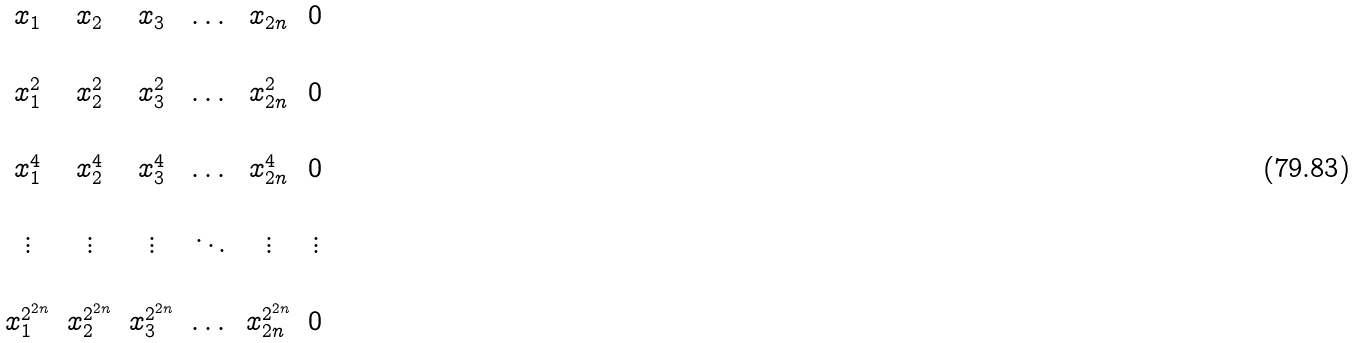<formula> <loc_0><loc_0><loc_500><loc_500>\begin{matrix} x _ { 1 } & x _ { 2 } & x _ { 3 } & \dots & x _ { 2 n } & 0 \\ \\ x _ { 1 } ^ { 2 } & x _ { 2 } ^ { 2 } & x _ { 3 } ^ { 2 } & \dots & x _ { 2 n } ^ { 2 } & 0 \\ \\ x _ { 1 } ^ { 4 } & x _ { 2 } ^ { 4 } & x _ { 3 } ^ { 4 } & \dots & x _ { 2 n } ^ { 4 } & 0 \\ \\ \vdots & \vdots & \vdots & \ddots & \vdots & \vdots \\ \\ x _ { 1 } ^ { 2 ^ { 2 n } } & x _ { 2 } ^ { 2 ^ { 2 n } } & x _ { 3 } ^ { 2 ^ { 2 n } } & \dots & x _ { 2 n } ^ { 2 ^ { 2 n } } & 0 \\ \end{matrix}</formula> 